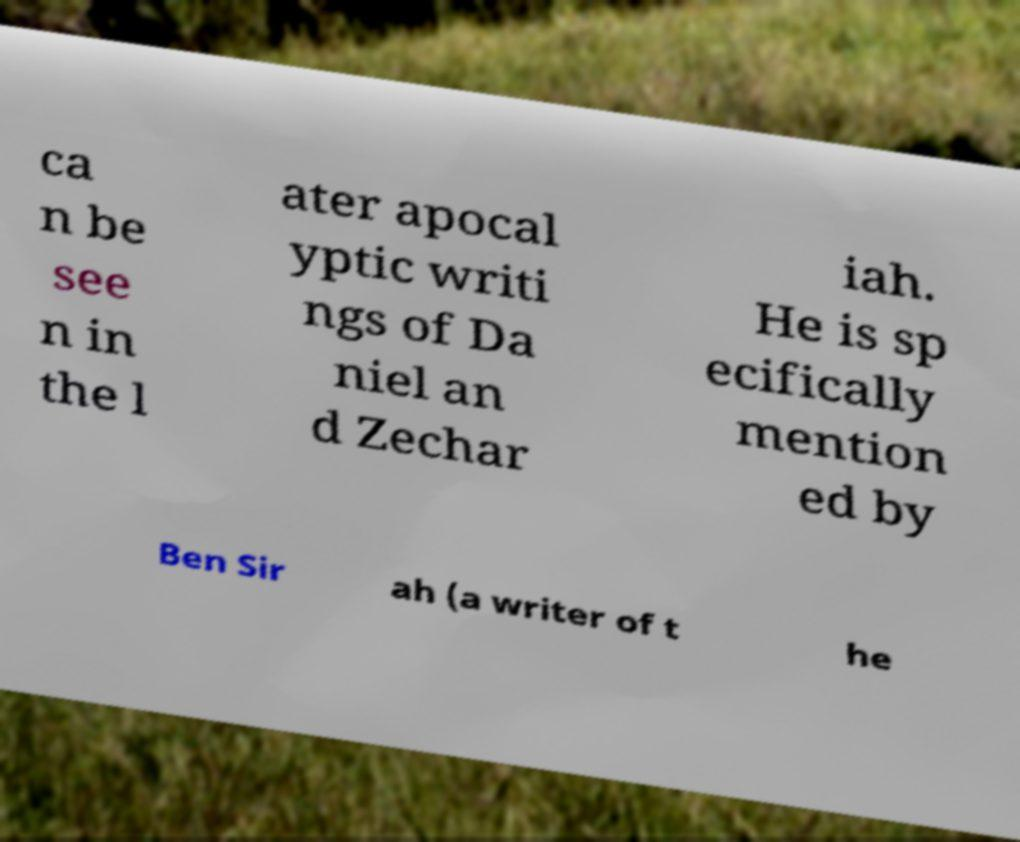Could you assist in decoding the text presented in this image and type it out clearly? ca n be see n in the l ater apocal yptic writi ngs of Da niel an d Zechar iah. He is sp ecifically mention ed by Ben Sir ah (a writer of t he 